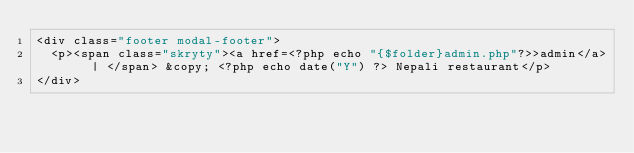<code> <loc_0><loc_0><loc_500><loc_500><_HTML_><div class="footer modal-footer">
  <p><span class="skryty"><a href=<?php echo "{$folder}admin.php"?>>admin</a> | </span> &copy; <?php echo date("Y") ?> Nepali restaurant</p>
</div>
</code> 